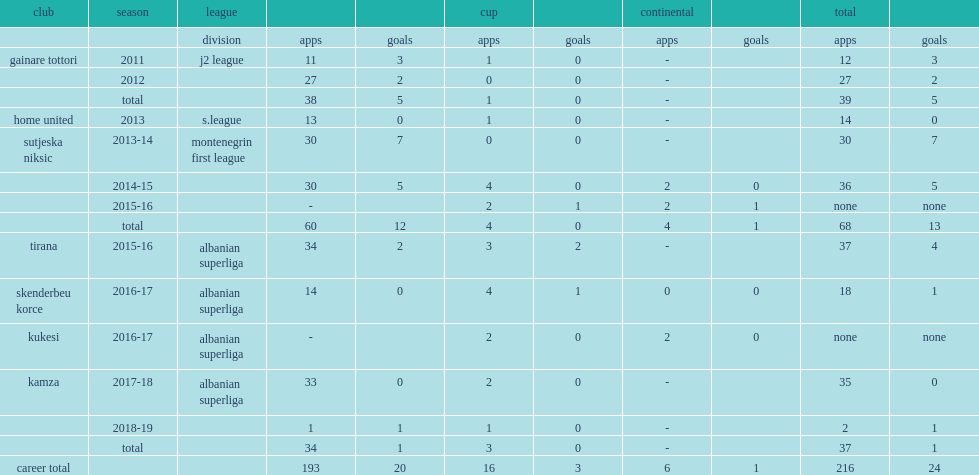Which club did masato fukui play for in 2011? Gainare tottori. 